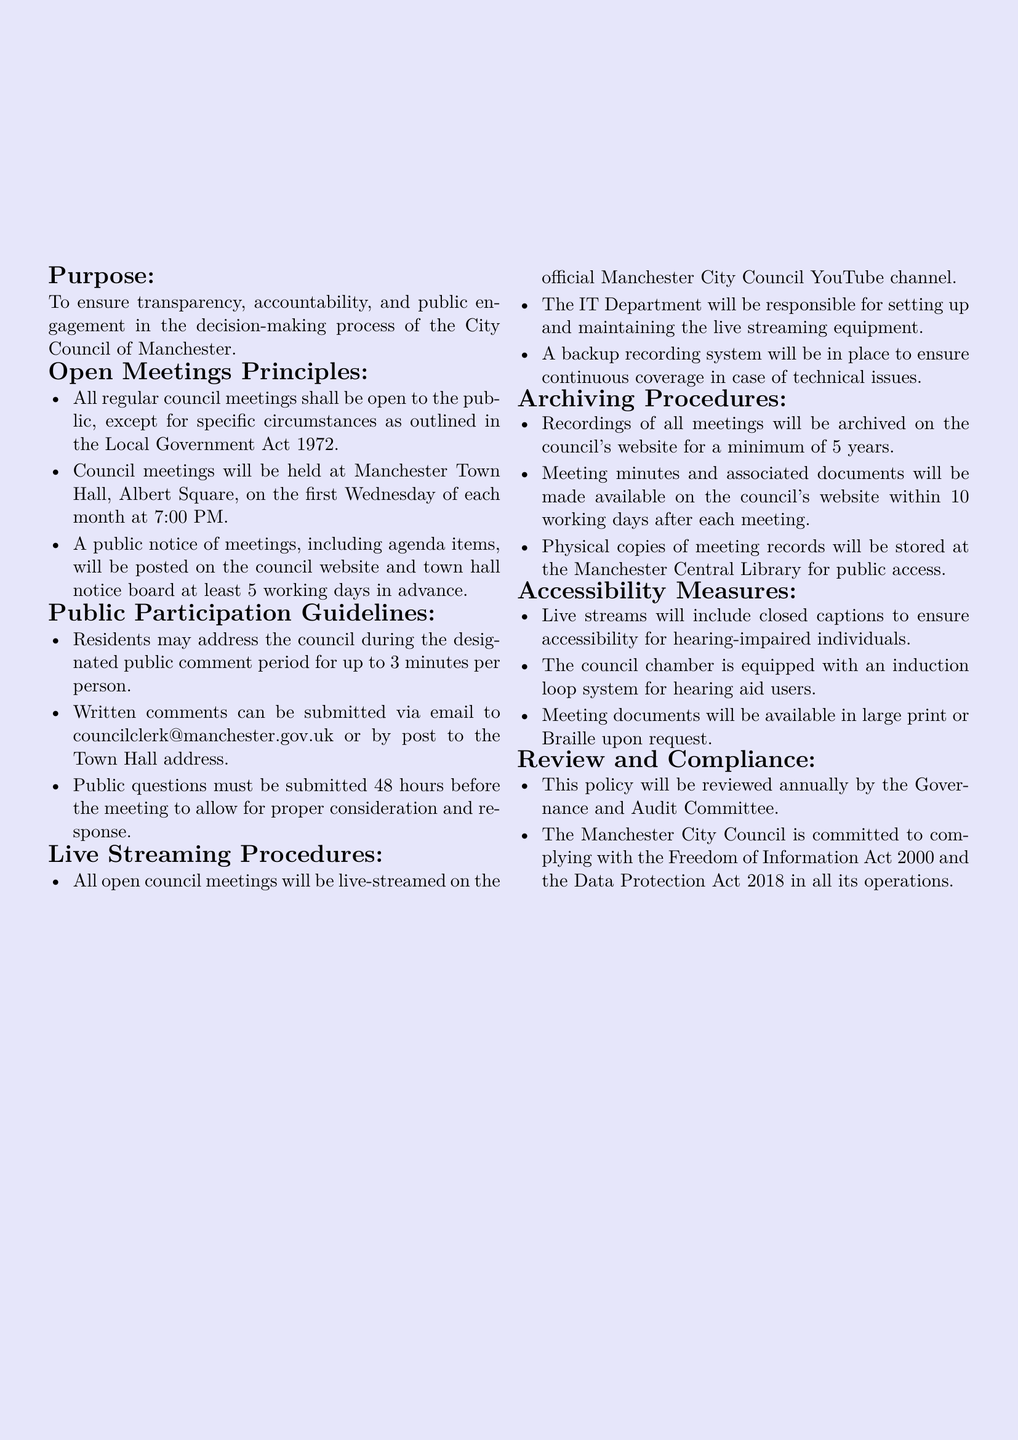What is the purpose of the policy? The purpose is to ensure transparency, accountability, and public engagement in the decision-making process of the City Council of Manchester.
Answer: To ensure transparency, accountability, and public engagement How often are council meetings held? Council meetings are scheduled as outlined in the Open Meetings Principles section of the document.
Answer: First Wednesday of each month What is the maximum duration for public comments? The guideline specifies the time allocated for each public speaker during the comment period.
Answer: 3 minutes Where will live streams of council meetings be available? The document mentions the platform where live streams will be hosted.
Answer: Official Manchester City Council YouTube channel How long will recorded meetings be archived on the website? The policy stipulates the minimum time frame for archiving recordings.
Answer: 5 years When must public questions be submitted? The timeline for submitting public questions is provided in the Public Participation Guidelines section.
Answer: 48 hours before the meeting What accessibility measure is included for hearing-impaired individuals? The document addresses specific accessibility provisions in the Accessibility Measures section.
Answer: Closed captions Who is responsible for maintaining the live streaming equipment? The responsibilities related to live streaming are outlined in the Live Streaming Procedures section.
Answer: IT Department How frequently will the policy be reviewed? The document specifies how often the review of the policy will occur.
Answer: Annually 